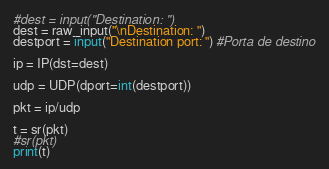<code> <loc_0><loc_0><loc_500><loc_500><_Python_>
#dest = input("Destination: ")
dest = raw_input("\nDestination: ")
destport = input("Destination port: ") #Porta de destino

ip = IP(dst=dest)

udp = UDP(dport=int(destport))

pkt = ip/udp

t = sr(pkt)
#sr(pkt)
print(t)
</code> 